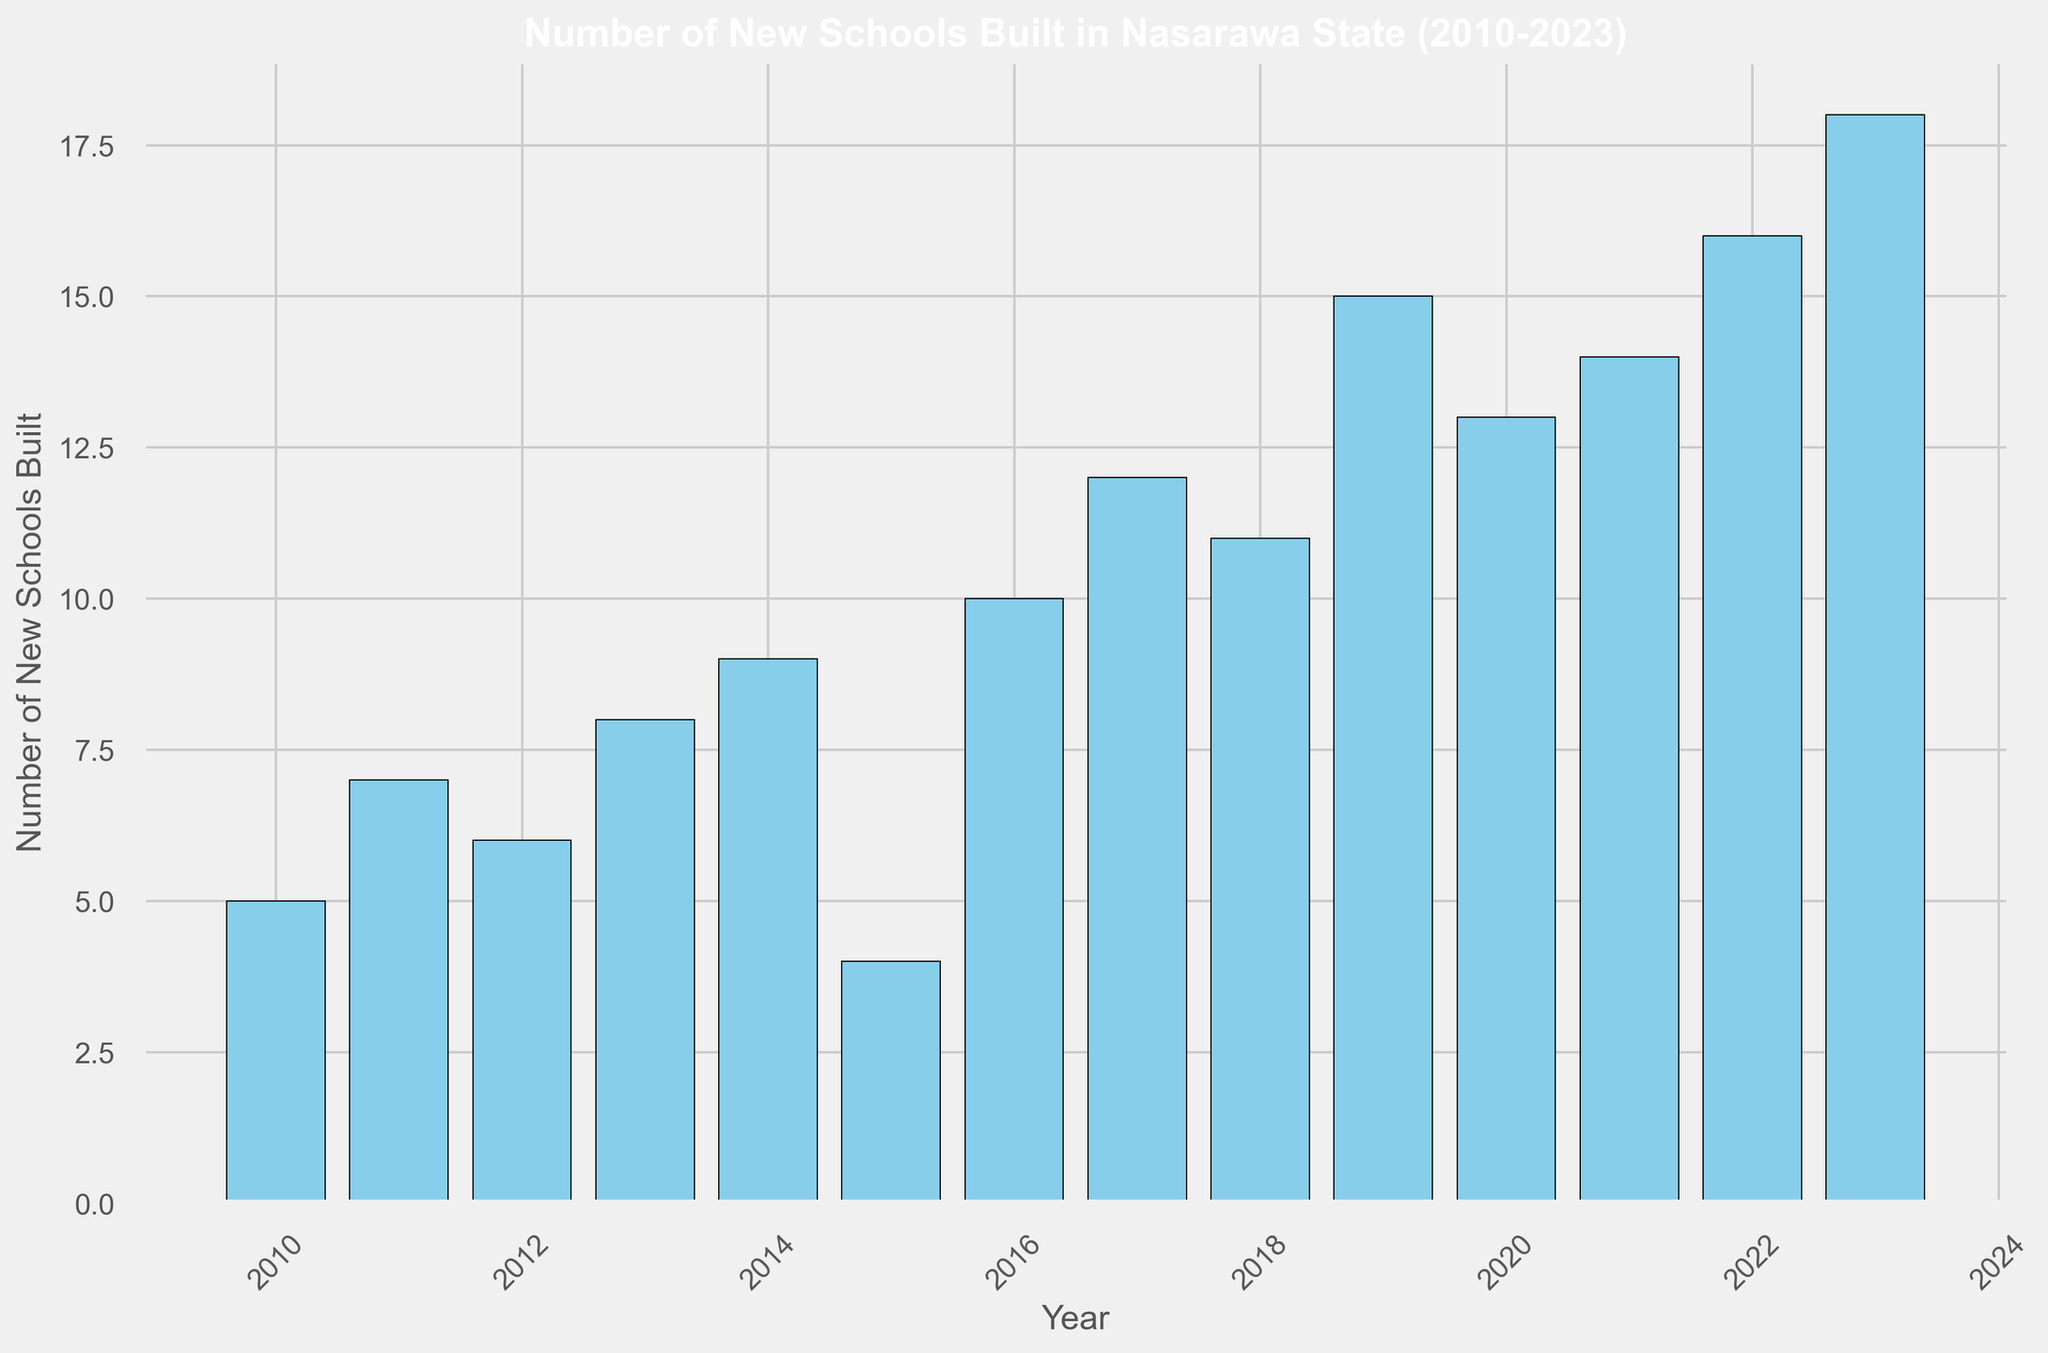Which year saw the highest number of new schools built? By examining the height of the bars, the tallest bar represents the year with the highest number. The year 2023 has the tallest bar at 18.
Answer: 2023 How many new schools were built in total from 2010 to 2015? Summing the number of new schools for each year from 2010 to 2015: 5 + 7 + 6 + 8 + 9 + 4 = 39.
Answer: 39 Which year had the lowest number of new schools built, and how many were built that year? The shortest bar represents the year with the lowest number of new schools built. The year 2015 has the shortest bar at 4.
Answer: 2015, 4 What is the average number of new schools built per year from 2020 to 2023? There are 4 years from 2020 to 2023. Adding the number of new schools built each year: 13 (2020) + 14 (2021) + 16 (2022) + 18 (2023) = 61. The average is 61 / 4 = 15.25.
Answer: 15.25 How did the number of new schools built in 2015 compare to the number built in 2016? Comparing the heights of the bars for 2015 and 2016: 2015 (4) is less than 2016 (10).
Answer: 2015 < 2016 In which period did the number of new schools built increase the most compared to the previous year? Looking at the differences between each consecutive year, the largest increase is from 2018 (11) to 2019 (15), which is an increase of 4.
Answer: 2018 to 2019 Between which years did the number of new schools built remain the same? Observing the bars, there were no consecutive years with the same number of new schools built.
Answer: None What is the median number of new schools built per year from 2010 to 2023? Listing the numbers in ascending order: 4, 5, 6, 7, 8, 9, 10, 11, 12, 13, 14, 15, 16, 18. The median, being the middle value, is the average of the 7th and 8th terms: (10 + 11) / 2 = 10.5.
Answer: 10.5 Which year had the third highest number of new schools built? By examining the heights of the bars and ranking them, the third highest is 14, which corresponds to the year 2021.
Answer: 2021 